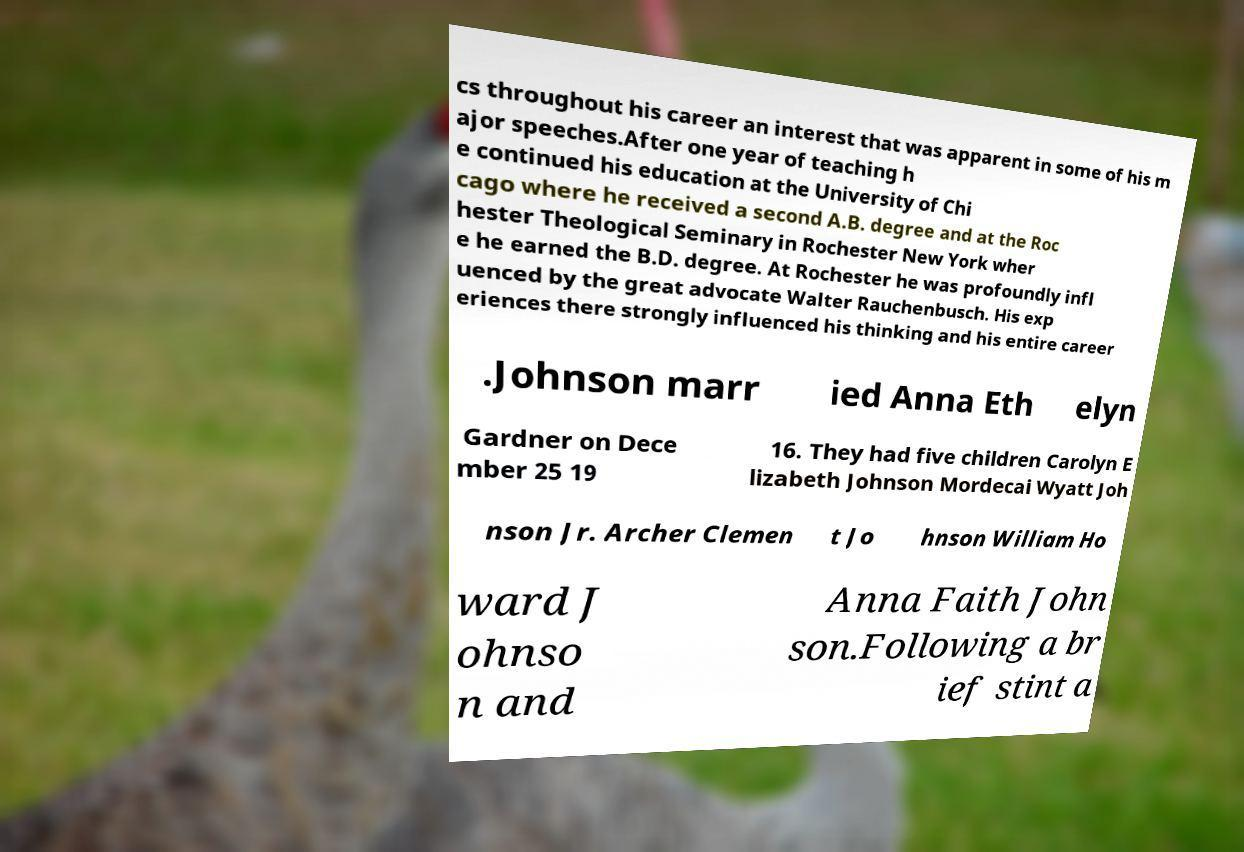For documentation purposes, I need the text within this image transcribed. Could you provide that? cs throughout his career an interest that was apparent in some of his m ajor speeches.After one year of teaching h e continued his education at the University of Chi cago where he received a second A.B. degree and at the Roc hester Theological Seminary in Rochester New York wher e he earned the B.D. degree. At Rochester he was profoundly infl uenced by the great advocate Walter Rauchenbusch. His exp eriences there strongly influenced his thinking and his entire career .Johnson marr ied Anna Eth elyn Gardner on Dece mber 25 19 16. They had five children Carolyn E lizabeth Johnson Mordecai Wyatt Joh nson Jr. Archer Clemen t Jo hnson William Ho ward J ohnso n and Anna Faith John son.Following a br ief stint a 